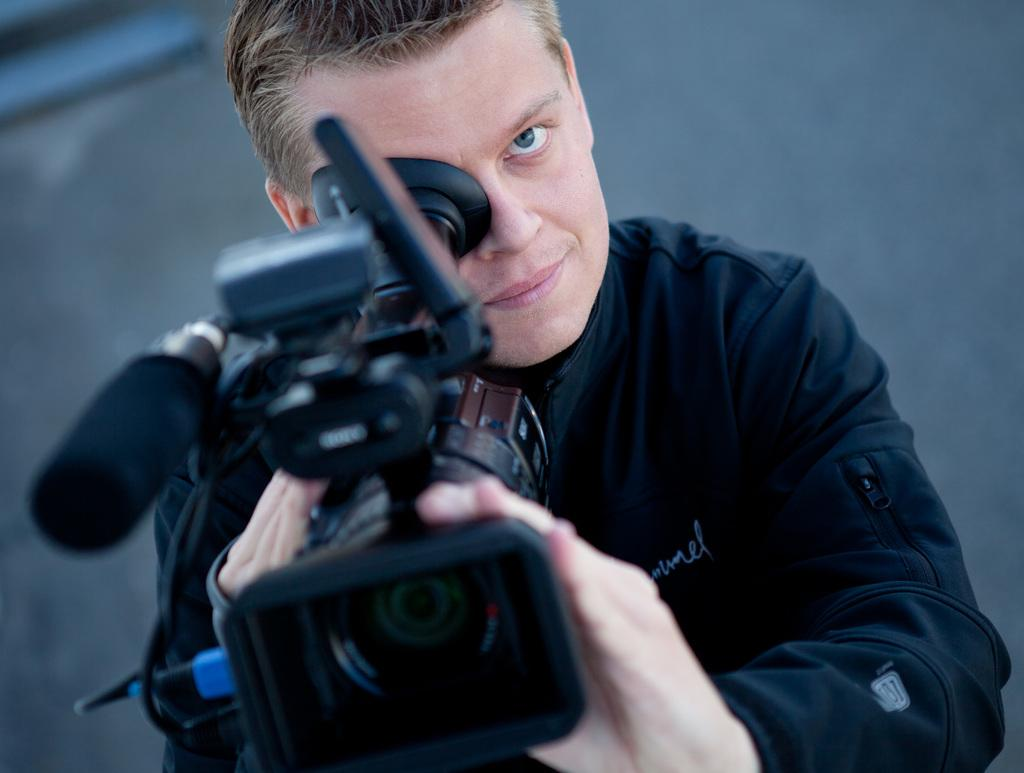Who is present in the image? There is a man in the image. What is the man doing in the image? The man is standing in the image. What object is the man holding in the image? The man is holding a camera in the image. What can be seen behind the man in the image? There is a wall behind the man in the image. What type of blood is visible on the man's hands in the image? There is no blood visible on the man's hands in the image. What kind of drum is the man playing in the image? There is no drum present in the image; the man is holding a camera. 